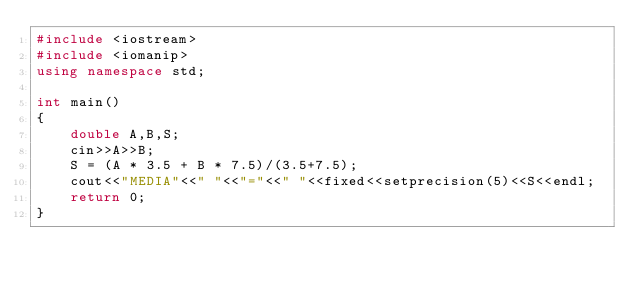<code> <loc_0><loc_0><loc_500><loc_500><_C++_>#include <iostream>
#include <iomanip>
using namespace std;

int main()
{
    double A,B,S;
    cin>>A>>B;
    S = (A * 3.5 + B * 7.5)/(3.5+7.5);
    cout<<"MEDIA"<<" "<<"="<<" "<<fixed<<setprecision(5)<<S<<endl;
    return 0;
}
</code> 